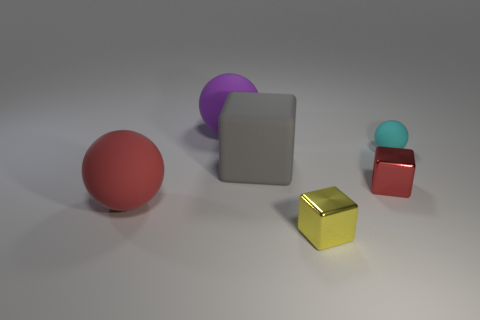Add 1 big matte objects. How many objects exist? 7 Add 6 green rubber cubes. How many green rubber cubes exist? 6 Subtract 0 blue spheres. How many objects are left? 6 Subtract all large red balls. Subtract all cyan spheres. How many objects are left? 4 Add 6 large red spheres. How many large red spheres are left? 7 